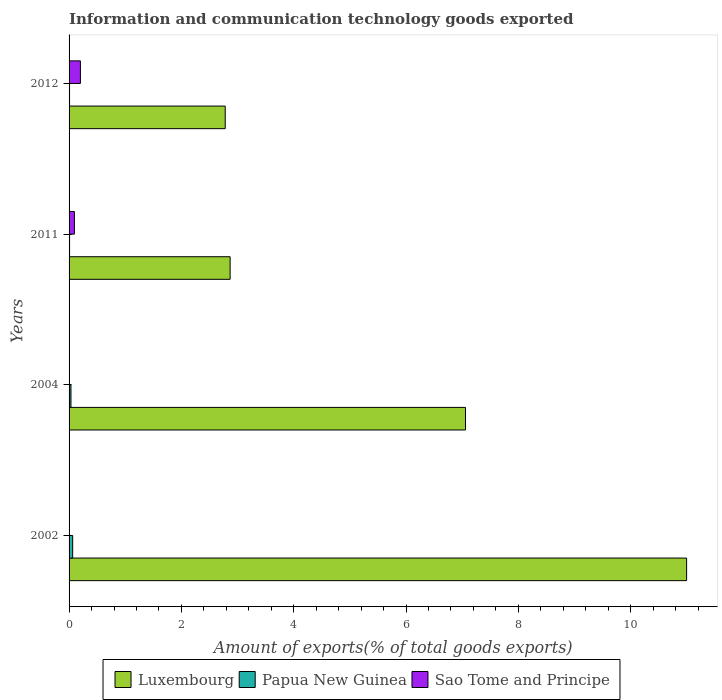How many groups of bars are there?
Your answer should be very brief. 4. What is the label of the 3rd group of bars from the top?
Your answer should be very brief. 2004. In how many cases, is the number of bars for a given year not equal to the number of legend labels?
Give a very brief answer. 0. What is the amount of goods exported in Sao Tome and Principe in 2004?
Give a very brief answer. 0. Across all years, what is the maximum amount of goods exported in Papua New Guinea?
Give a very brief answer. 0.06. Across all years, what is the minimum amount of goods exported in Papua New Guinea?
Offer a very short reply. 0.01. What is the total amount of goods exported in Papua New Guinea in the graph?
Offer a terse response. 0.12. What is the difference between the amount of goods exported in Luxembourg in 2002 and that in 2011?
Offer a terse response. 8.13. What is the difference between the amount of goods exported in Papua New Guinea in 2012 and the amount of goods exported in Sao Tome and Principe in 2002?
Your answer should be very brief. 0.01. What is the average amount of goods exported in Sao Tome and Principe per year?
Keep it short and to the point. 0.08. In the year 2012, what is the difference between the amount of goods exported in Luxembourg and amount of goods exported in Sao Tome and Principe?
Your answer should be compact. 2.58. What is the ratio of the amount of goods exported in Luxembourg in 2004 to that in 2011?
Provide a short and direct response. 2.46. Is the amount of goods exported in Papua New Guinea in 2011 less than that in 2012?
Keep it short and to the point. No. What is the difference between the highest and the second highest amount of goods exported in Papua New Guinea?
Give a very brief answer. 0.03. What is the difference between the highest and the lowest amount of goods exported in Luxembourg?
Give a very brief answer. 8.22. In how many years, is the amount of goods exported in Luxembourg greater than the average amount of goods exported in Luxembourg taken over all years?
Ensure brevity in your answer.  2. What does the 3rd bar from the top in 2011 represents?
Keep it short and to the point. Luxembourg. What does the 2nd bar from the bottom in 2011 represents?
Offer a terse response. Papua New Guinea. Is it the case that in every year, the sum of the amount of goods exported in Sao Tome and Principe and amount of goods exported in Papua New Guinea is greater than the amount of goods exported in Luxembourg?
Ensure brevity in your answer.  No. How many bars are there?
Ensure brevity in your answer.  12. Are all the bars in the graph horizontal?
Make the answer very short. Yes. How many years are there in the graph?
Keep it short and to the point. 4. Does the graph contain any zero values?
Make the answer very short. No. Where does the legend appear in the graph?
Your answer should be very brief. Bottom center. How are the legend labels stacked?
Offer a terse response. Horizontal. What is the title of the graph?
Give a very brief answer. Information and communication technology goods exported. What is the label or title of the X-axis?
Provide a succinct answer. Amount of exports(% of total goods exports). What is the Amount of exports(% of total goods exports) of Luxembourg in 2002?
Your answer should be very brief. 11. What is the Amount of exports(% of total goods exports) in Papua New Guinea in 2002?
Offer a very short reply. 0.06. What is the Amount of exports(% of total goods exports) in Sao Tome and Principe in 2002?
Your answer should be very brief. 0. What is the Amount of exports(% of total goods exports) of Luxembourg in 2004?
Keep it short and to the point. 7.06. What is the Amount of exports(% of total goods exports) in Papua New Guinea in 2004?
Offer a terse response. 0.03. What is the Amount of exports(% of total goods exports) of Sao Tome and Principe in 2004?
Your answer should be compact. 0. What is the Amount of exports(% of total goods exports) in Luxembourg in 2011?
Make the answer very short. 2.87. What is the Amount of exports(% of total goods exports) in Papua New Guinea in 2011?
Your answer should be compact. 0.01. What is the Amount of exports(% of total goods exports) of Sao Tome and Principe in 2011?
Offer a very short reply. 0.1. What is the Amount of exports(% of total goods exports) of Luxembourg in 2012?
Ensure brevity in your answer.  2.78. What is the Amount of exports(% of total goods exports) of Papua New Guinea in 2012?
Provide a short and direct response. 0.01. What is the Amount of exports(% of total goods exports) of Sao Tome and Principe in 2012?
Make the answer very short. 0.2. Across all years, what is the maximum Amount of exports(% of total goods exports) in Luxembourg?
Offer a very short reply. 11. Across all years, what is the maximum Amount of exports(% of total goods exports) of Papua New Guinea?
Provide a succinct answer. 0.06. Across all years, what is the maximum Amount of exports(% of total goods exports) of Sao Tome and Principe?
Offer a terse response. 0.2. Across all years, what is the minimum Amount of exports(% of total goods exports) of Luxembourg?
Give a very brief answer. 2.78. Across all years, what is the minimum Amount of exports(% of total goods exports) in Papua New Guinea?
Offer a very short reply. 0.01. Across all years, what is the minimum Amount of exports(% of total goods exports) of Sao Tome and Principe?
Provide a succinct answer. 0. What is the total Amount of exports(% of total goods exports) in Luxembourg in the graph?
Provide a short and direct response. 23.7. What is the total Amount of exports(% of total goods exports) in Papua New Guinea in the graph?
Provide a short and direct response. 0.12. What is the total Amount of exports(% of total goods exports) of Sao Tome and Principe in the graph?
Keep it short and to the point. 0.3. What is the difference between the Amount of exports(% of total goods exports) of Luxembourg in 2002 and that in 2004?
Ensure brevity in your answer.  3.94. What is the difference between the Amount of exports(% of total goods exports) in Papua New Guinea in 2002 and that in 2004?
Your response must be concise. 0.03. What is the difference between the Amount of exports(% of total goods exports) in Sao Tome and Principe in 2002 and that in 2004?
Your answer should be very brief. -0. What is the difference between the Amount of exports(% of total goods exports) in Luxembourg in 2002 and that in 2011?
Offer a very short reply. 8.13. What is the difference between the Amount of exports(% of total goods exports) in Papua New Guinea in 2002 and that in 2011?
Offer a very short reply. 0.06. What is the difference between the Amount of exports(% of total goods exports) in Sao Tome and Principe in 2002 and that in 2011?
Make the answer very short. -0.09. What is the difference between the Amount of exports(% of total goods exports) of Luxembourg in 2002 and that in 2012?
Your answer should be compact. 8.22. What is the difference between the Amount of exports(% of total goods exports) of Papua New Guinea in 2002 and that in 2012?
Offer a very short reply. 0.06. What is the difference between the Amount of exports(% of total goods exports) of Sao Tome and Principe in 2002 and that in 2012?
Keep it short and to the point. -0.2. What is the difference between the Amount of exports(% of total goods exports) of Luxembourg in 2004 and that in 2011?
Keep it short and to the point. 4.19. What is the difference between the Amount of exports(% of total goods exports) in Papua New Guinea in 2004 and that in 2011?
Give a very brief answer. 0.02. What is the difference between the Amount of exports(% of total goods exports) of Sao Tome and Principe in 2004 and that in 2011?
Ensure brevity in your answer.  -0.09. What is the difference between the Amount of exports(% of total goods exports) in Luxembourg in 2004 and that in 2012?
Your response must be concise. 4.28. What is the difference between the Amount of exports(% of total goods exports) of Papua New Guinea in 2004 and that in 2012?
Offer a terse response. 0.03. What is the difference between the Amount of exports(% of total goods exports) in Sao Tome and Principe in 2004 and that in 2012?
Offer a very short reply. -0.2. What is the difference between the Amount of exports(% of total goods exports) of Luxembourg in 2011 and that in 2012?
Offer a very short reply. 0.09. What is the difference between the Amount of exports(% of total goods exports) of Papua New Guinea in 2011 and that in 2012?
Give a very brief answer. 0. What is the difference between the Amount of exports(% of total goods exports) of Sao Tome and Principe in 2011 and that in 2012?
Offer a very short reply. -0.11. What is the difference between the Amount of exports(% of total goods exports) in Luxembourg in 2002 and the Amount of exports(% of total goods exports) in Papua New Guinea in 2004?
Your response must be concise. 10.96. What is the difference between the Amount of exports(% of total goods exports) of Luxembourg in 2002 and the Amount of exports(% of total goods exports) of Sao Tome and Principe in 2004?
Offer a terse response. 10.99. What is the difference between the Amount of exports(% of total goods exports) of Papua New Guinea in 2002 and the Amount of exports(% of total goods exports) of Sao Tome and Principe in 2004?
Keep it short and to the point. 0.06. What is the difference between the Amount of exports(% of total goods exports) in Luxembourg in 2002 and the Amount of exports(% of total goods exports) in Papua New Guinea in 2011?
Make the answer very short. 10.99. What is the difference between the Amount of exports(% of total goods exports) in Luxembourg in 2002 and the Amount of exports(% of total goods exports) in Sao Tome and Principe in 2011?
Ensure brevity in your answer.  10.9. What is the difference between the Amount of exports(% of total goods exports) in Papua New Guinea in 2002 and the Amount of exports(% of total goods exports) in Sao Tome and Principe in 2011?
Make the answer very short. -0.03. What is the difference between the Amount of exports(% of total goods exports) of Luxembourg in 2002 and the Amount of exports(% of total goods exports) of Papua New Guinea in 2012?
Provide a succinct answer. 10.99. What is the difference between the Amount of exports(% of total goods exports) in Luxembourg in 2002 and the Amount of exports(% of total goods exports) in Sao Tome and Principe in 2012?
Your answer should be compact. 10.79. What is the difference between the Amount of exports(% of total goods exports) in Papua New Guinea in 2002 and the Amount of exports(% of total goods exports) in Sao Tome and Principe in 2012?
Your answer should be compact. -0.14. What is the difference between the Amount of exports(% of total goods exports) of Luxembourg in 2004 and the Amount of exports(% of total goods exports) of Papua New Guinea in 2011?
Give a very brief answer. 7.05. What is the difference between the Amount of exports(% of total goods exports) of Luxembourg in 2004 and the Amount of exports(% of total goods exports) of Sao Tome and Principe in 2011?
Make the answer very short. 6.96. What is the difference between the Amount of exports(% of total goods exports) in Papua New Guinea in 2004 and the Amount of exports(% of total goods exports) in Sao Tome and Principe in 2011?
Your answer should be very brief. -0.06. What is the difference between the Amount of exports(% of total goods exports) of Luxembourg in 2004 and the Amount of exports(% of total goods exports) of Papua New Guinea in 2012?
Your answer should be very brief. 7.05. What is the difference between the Amount of exports(% of total goods exports) in Luxembourg in 2004 and the Amount of exports(% of total goods exports) in Sao Tome and Principe in 2012?
Your answer should be very brief. 6.86. What is the difference between the Amount of exports(% of total goods exports) of Papua New Guinea in 2004 and the Amount of exports(% of total goods exports) of Sao Tome and Principe in 2012?
Give a very brief answer. -0.17. What is the difference between the Amount of exports(% of total goods exports) of Luxembourg in 2011 and the Amount of exports(% of total goods exports) of Papua New Guinea in 2012?
Your answer should be very brief. 2.86. What is the difference between the Amount of exports(% of total goods exports) in Luxembourg in 2011 and the Amount of exports(% of total goods exports) in Sao Tome and Principe in 2012?
Offer a terse response. 2.67. What is the difference between the Amount of exports(% of total goods exports) of Papua New Guinea in 2011 and the Amount of exports(% of total goods exports) of Sao Tome and Principe in 2012?
Your answer should be compact. -0.19. What is the average Amount of exports(% of total goods exports) in Luxembourg per year?
Keep it short and to the point. 5.93. What is the average Amount of exports(% of total goods exports) of Papua New Guinea per year?
Your response must be concise. 0.03. What is the average Amount of exports(% of total goods exports) of Sao Tome and Principe per year?
Provide a short and direct response. 0.08. In the year 2002, what is the difference between the Amount of exports(% of total goods exports) in Luxembourg and Amount of exports(% of total goods exports) in Papua New Guinea?
Your answer should be compact. 10.93. In the year 2002, what is the difference between the Amount of exports(% of total goods exports) of Luxembourg and Amount of exports(% of total goods exports) of Sao Tome and Principe?
Make the answer very short. 10.99. In the year 2002, what is the difference between the Amount of exports(% of total goods exports) in Papua New Guinea and Amount of exports(% of total goods exports) in Sao Tome and Principe?
Offer a very short reply. 0.06. In the year 2004, what is the difference between the Amount of exports(% of total goods exports) in Luxembourg and Amount of exports(% of total goods exports) in Papua New Guinea?
Make the answer very short. 7.02. In the year 2004, what is the difference between the Amount of exports(% of total goods exports) of Luxembourg and Amount of exports(% of total goods exports) of Sao Tome and Principe?
Give a very brief answer. 7.06. In the year 2004, what is the difference between the Amount of exports(% of total goods exports) of Papua New Guinea and Amount of exports(% of total goods exports) of Sao Tome and Principe?
Ensure brevity in your answer.  0.03. In the year 2011, what is the difference between the Amount of exports(% of total goods exports) in Luxembourg and Amount of exports(% of total goods exports) in Papua New Guinea?
Your answer should be compact. 2.86. In the year 2011, what is the difference between the Amount of exports(% of total goods exports) of Luxembourg and Amount of exports(% of total goods exports) of Sao Tome and Principe?
Provide a succinct answer. 2.77. In the year 2011, what is the difference between the Amount of exports(% of total goods exports) of Papua New Guinea and Amount of exports(% of total goods exports) of Sao Tome and Principe?
Your response must be concise. -0.09. In the year 2012, what is the difference between the Amount of exports(% of total goods exports) of Luxembourg and Amount of exports(% of total goods exports) of Papua New Guinea?
Make the answer very short. 2.77. In the year 2012, what is the difference between the Amount of exports(% of total goods exports) of Luxembourg and Amount of exports(% of total goods exports) of Sao Tome and Principe?
Offer a very short reply. 2.58. In the year 2012, what is the difference between the Amount of exports(% of total goods exports) in Papua New Guinea and Amount of exports(% of total goods exports) in Sao Tome and Principe?
Your response must be concise. -0.19. What is the ratio of the Amount of exports(% of total goods exports) of Luxembourg in 2002 to that in 2004?
Keep it short and to the point. 1.56. What is the ratio of the Amount of exports(% of total goods exports) of Papua New Guinea in 2002 to that in 2004?
Keep it short and to the point. 1.89. What is the ratio of the Amount of exports(% of total goods exports) of Sao Tome and Principe in 2002 to that in 2004?
Offer a very short reply. 0.72. What is the ratio of the Amount of exports(% of total goods exports) in Luxembourg in 2002 to that in 2011?
Offer a terse response. 3.83. What is the ratio of the Amount of exports(% of total goods exports) in Papua New Guinea in 2002 to that in 2011?
Keep it short and to the point. 7.07. What is the ratio of the Amount of exports(% of total goods exports) of Sao Tome and Principe in 2002 to that in 2011?
Ensure brevity in your answer.  0.02. What is the ratio of the Amount of exports(% of total goods exports) of Luxembourg in 2002 to that in 2012?
Your response must be concise. 3.95. What is the ratio of the Amount of exports(% of total goods exports) of Papua New Guinea in 2002 to that in 2012?
Offer a terse response. 7.65. What is the ratio of the Amount of exports(% of total goods exports) in Sao Tome and Principe in 2002 to that in 2012?
Ensure brevity in your answer.  0.01. What is the ratio of the Amount of exports(% of total goods exports) of Luxembourg in 2004 to that in 2011?
Your response must be concise. 2.46. What is the ratio of the Amount of exports(% of total goods exports) of Papua New Guinea in 2004 to that in 2011?
Make the answer very short. 3.73. What is the ratio of the Amount of exports(% of total goods exports) in Sao Tome and Principe in 2004 to that in 2011?
Keep it short and to the point. 0.03. What is the ratio of the Amount of exports(% of total goods exports) of Luxembourg in 2004 to that in 2012?
Ensure brevity in your answer.  2.54. What is the ratio of the Amount of exports(% of total goods exports) in Papua New Guinea in 2004 to that in 2012?
Your answer should be compact. 4.04. What is the ratio of the Amount of exports(% of total goods exports) of Sao Tome and Principe in 2004 to that in 2012?
Offer a very short reply. 0.01. What is the ratio of the Amount of exports(% of total goods exports) of Luxembourg in 2011 to that in 2012?
Your answer should be very brief. 1.03. What is the ratio of the Amount of exports(% of total goods exports) in Papua New Guinea in 2011 to that in 2012?
Offer a terse response. 1.08. What is the ratio of the Amount of exports(% of total goods exports) of Sao Tome and Principe in 2011 to that in 2012?
Your answer should be compact. 0.47. What is the difference between the highest and the second highest Amount of exports(% of total goods exports) in Luxembourg?
Ensure brevity in your answer.  3.94. What is the difference between the highest and the second highest Amount of exports(% of total goods exports) of Papua New Guinea?
Your answer should be compact. 0.03. What is the difference between the highest and the second highest Amount of exports(% of total goods exports) of Sao Tome and Principe?
Give a very brief answer. 0.11. What is the difference between the highest and the lowest Amount of exports(% of total goods exports) in Luxembourg?
Your answer should be very brief. 8.22. What is the difference between the highest and the lowest Amount of exports(% of total goods exports) in Papua New Guinea?
Give a very brief answer. 0.06. What is the difference between the highest and the lowest Amount of exports(% of total goods exports) of Sao Tome and Principe?
Provide a succinct answer. 0.2. 